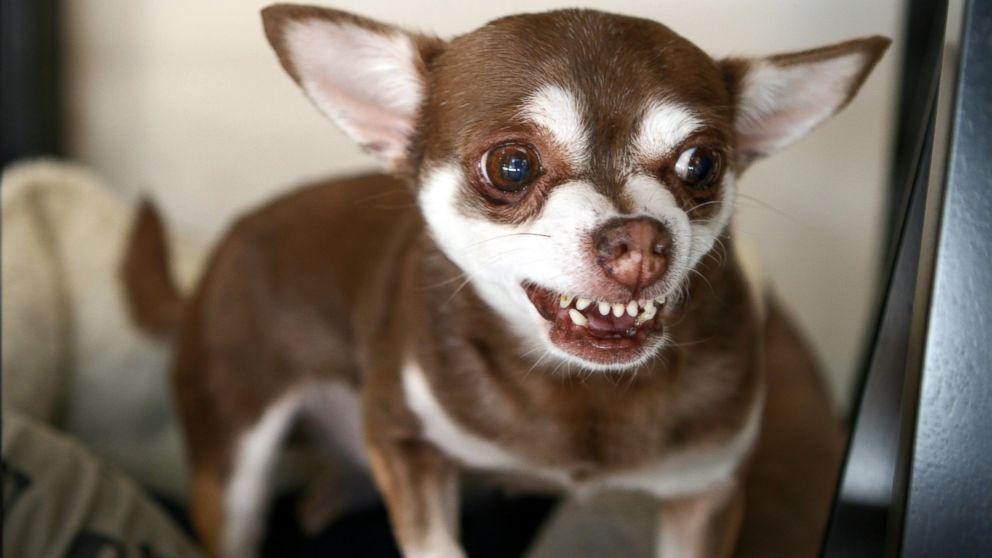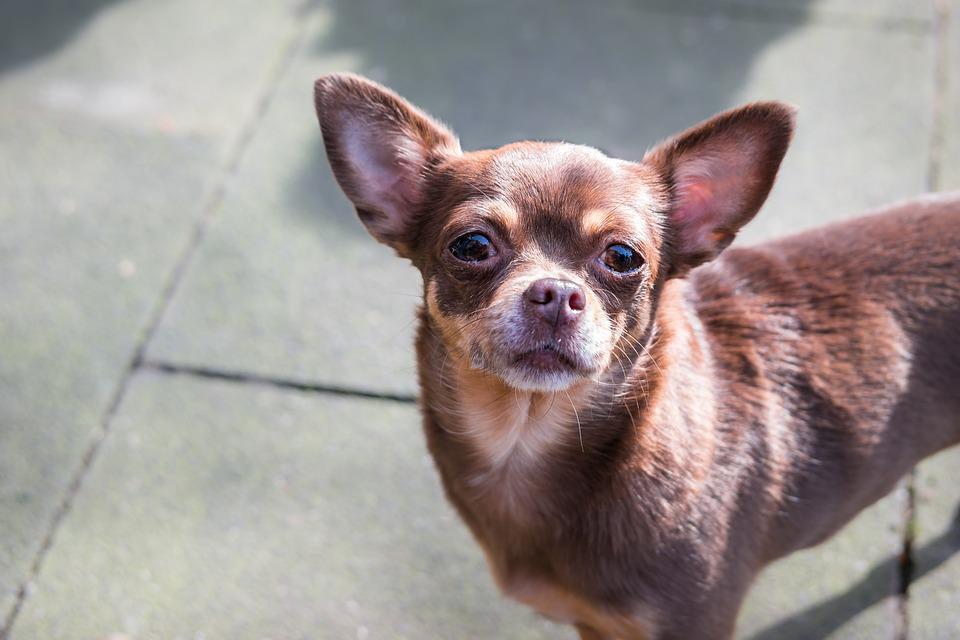The first image is the image on the left, the second image is the image on the right. Assess this claim about the two images: "There is only one dog baring its teeth, in total.". Correct or not? Answer yes or no. Yes. The first image is the image on the left, the second image is the image on the right. Analyze the images presented: Is the assertion "The dog in the image on the left is baring its teeth." valid? Answer yes or no. Yes. 